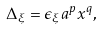Convert formula to latex. <formula><loc_0><loc_0><loc_500><loc_500>\Delta _ { \xi } = \epsilon _ { \xi } a ^ { p } x ^ { q } ,</formula> 